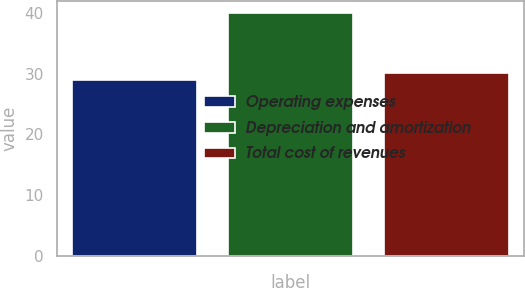Convert chart. <chart><loc_0><loc_0><loc_500><loc_500><bar_chart><fcel>Operating expenses<fcel>Depreciation and amortization<fcel>Total cost of revenues<nl><fcel>29<fcel>40<fcel>30.1<nl></chart> 